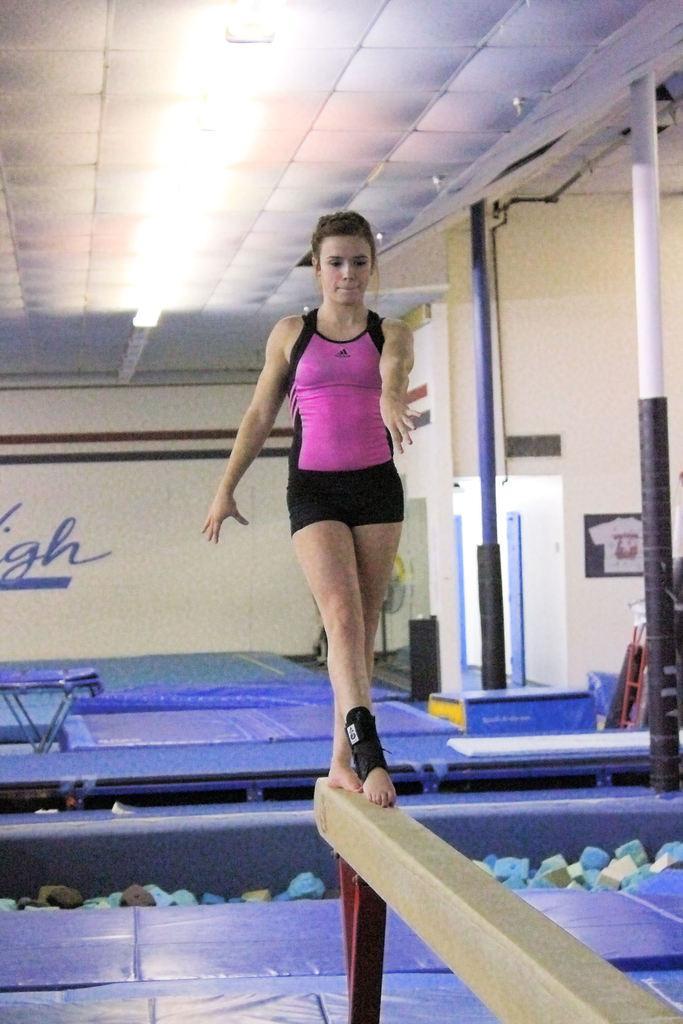Describe this image in one or two sentences. At the top we can see the ceiling and lights. In this picture we can see a woman is standing on a pole. We can see few objects. On the right side of the picture we can see the poles. We can see a poster on the wall. 